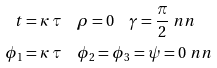Convert formula to latex. <formula><loc_0><loc_0><loc_500><loc_500>t & = \kappa \, \tau \quad \rho = 0 \quad \gamma = \frac { \pi } { 2 } \ n n \\ \phi _ { 1 } & = \kappa \, \tau \quad \phi _ { 2 } = \phi _ { 3 } = \psi = 0 \ n n</formula> 